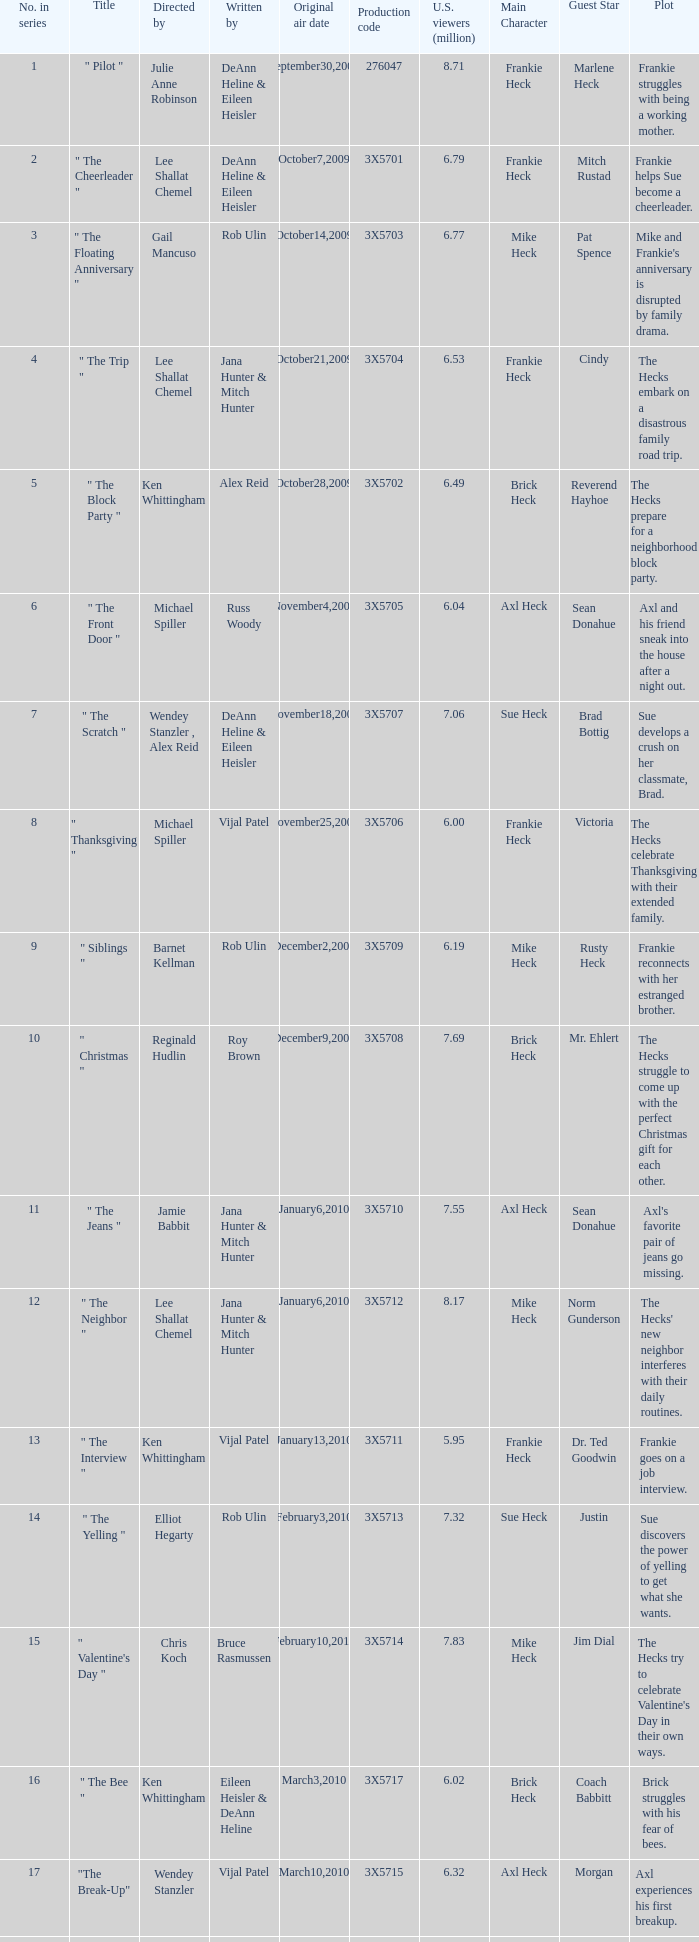Help me parse the entirety of this table. {'header': ['No. in series', 'Title', 'Directed by', 'Written by', 'Original air date', 'Production code', 'U.S. viewers (million)', 'Main Character', 'Guest Star', 'Plot'], 'rows': [['1', '" Pilot "', 'Julie Anne Robinson', 'DeAnn Heline & Eileen Heisler', 'September30,2009', '276047', '8.71', 'Frankie Heck', 'Marlene Heck', 'Frankie struggles with being a working mother.'], ['2', '" The Cheerleader "', 'Lee Shallat Chemel', 'DeAnn Heline & Eileen Heisler', 'October7,2009', '3X5701', '6.79', 'Frankie Heck', 'Mitch Rustad', 'Frankie helps Sue become a cheerleader.'], ['3', '" The Floating Anniversary "', 'Gail Mancuso', 'Rob Ulin', 'October14,2009', '3X5703', '6.77', 'Mike Heck', 'Pat Spence', "Mike and Frankie's anniversary is disrupted by family drama."], ['4', '" The Trip "', 'Lee Shallat Chemel', 'Jana Hunter & Mitch Hunter', 'October21,2009', '3X5704', '6.53', 'Frankie Heck', 'Cindy', 'The Hecks embark on a disastrous family road trip.'], ['5', '" The Block Party "', 'Ken Whittingham', 'Alex Reid', 'October28,2009', '3X5702', '6.49', 'Brick Heck', 'Reverend Hayhoe', 'The Hecks prepare for a neighborhood block party.'], ['6', '" The Front Door "', 'Michael Spiller', 'Russ Woody', 'November4,2009', '3X5705', '6.04', 'Axl Heck', 'Sean Donahue', 'Axl and his friend sneak into the house after a night out.'], ['7', '" The Scratch "', 'Wendey Stanzler , Alex Reid', 'DeAnn Heline & Eileen Heisler', 'November18,2009', '3X5707', '7.06', 'Sue Heck', 'Brad Bottig', 'Sue develops a crush on her classmate, Brad.'], ['8', '" Thanksgiving "', 'Michael Spiller', 'Vijal Patel', 'November25,2009', '3X5706', '6.00', 'Frankie Heck', 'Victoria', 'The Hecks celebrate Thanksgiving with their extended family.'], ['9', '" Siblings "', 'Barnet Kellman', 'Rob Ulin', 'December2,2009', '3X5709', '6.19', 'Mike Heck', 'Rusty Heck', 'Frankie reconnects with her estranged brother.'], ['10', '" Christmas "', 'Reginald Hudlin', 'Roy Brown', 'December9,2009', '3X5708', '7.69', 'Brick Heck', 'Mr. Ehlert', 'The Hecks struggle to come up with the perfect Christmas gift for each other.'], ['11', '" The Jeans "', 'Jamie Babbit', 'Jana Hunter & Mitch Hunter', 'January6,2010', '3X5710', '7.55', 'Axl Heck', 'Sean Donahue', "Axl's favorite pair of jeans go missing."], ['12', '" The Neighbor "', 'Lee Shallat Chemel', 'Jana Hunter & Mitch Hunter', 'January6,2010', '3X5712', '8.17', 'Mike Heck', 'Norm Gunderson', "The Hecks' new neighbor interferes with their daily routines."], ['13', '" The Interview "', 'Ken Whittingham', 'Vijal Patel', 'January13,2010', '3X5711', '5.95', 'Frankie Heck', 'Dr. Ted Goodwin', 'Frankie goes on a job interview.'], ['14', '" The Yelling "', 'Elliot Hegarty', 'Rob Ulin', 'February3,2010', '3X5713', '7.32', 'Sue Heck', 'Justin', 'Sue discovers the power of yelling to get what she wants.'], ['15', '" Valentine\'s Day "', 'Chris Koch', 'Bruce Rasmussen', 'February10,2010', '3X5714', '7.83', 'Mike Heck', 'Jim Dial', "The Hecks try to celebrate Valentine's Day in their own ways."], ['16', '" The Bee "', 'Ken Whittingham', 'Eileen Heisler & DeAnn Heline', 'March3,2010', '3X5717', '6.02', 'Brick Heck', 'Coach Babbitt', 'Brick struggles with his fear of bees.'], ['17', '"The Break-Up"', 'Wendey Stanzler', 'Vijal Patel', 'March10,2010', '3X5715', '6.32', 'Axl Heck', 'Morgan', 'Axl experiences his first breakup.'], ['18', '"The Fun House"', 'Chris Koch', 'Roy Brown', 'March24,2010', '3X5716', '7.16', 'Mike Heck', 'Reverend TimTom', 'The Hecks visit a state fair and get lost in a funhouse.'], ['19', '"The Final Four"', 'Alex Reid', 'Rob Ulin', 'March31,2010', '3X5719', '6.23', 'Frankie Heck', 'Darrin', 'The Hecks join in on March Madness festivities.'], ['20', '"TV or Not TV"', 'Lee Shallat Chemel', 'Vijal Patel', 'April14,2010', '3X5718', '6.70', 'Sue Heck', 'Carly', 'Sue tries to win over her crush with a televised message.'], ['21', '"Worry Duty"', 'Lee Shallat Chemel', 'Bruce Rasmussen', 'April28,2010', '3X5720', '7.10', 'Frankie Heck', "Pam Freakin' Staggs", 'Frankie obsesses over her dental appointment.'], ['22', '"Mother\'s Day"', 'Barnet Kellman', 'Mitch Hunter & Jana Hunter', 'May5,2010', '3X5721', '6.75', 'Frankie Heck', 'Janet', "The Hecks celebrate Mother's Day."], ['23', '"Signals"', 'Jamie Babbit', 'DeAnn Heline & Eileen Heisler', 'May12,2010', '3X5722', '7.49', 'Axl Heck', 'Two-Time', 'Axl struggles to make a decision about his future.']]} How many directors attracted 6.79 million u.s. viewers for their episodes? 1.0. 